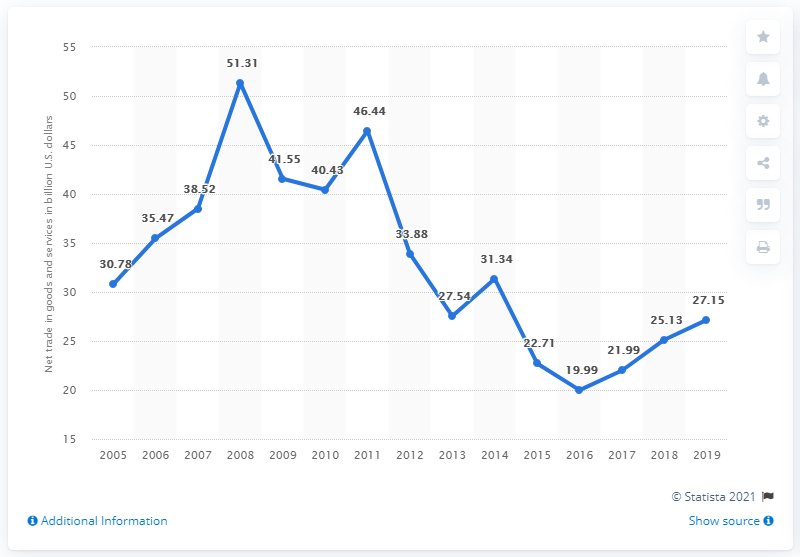Identify some key points in this picture. In 2011, Malaysia's net trade in goods and services was 46.44. The net trade has been under 30 for more than 6 years. The net trade in goods and services in Malaysia in 2019 was 27.15. The line reached its peak in 2008. 